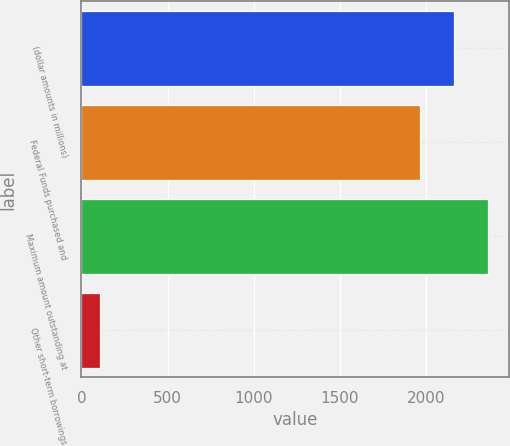Convert chart. <chart><loc_0><loc_0><loc_500><loc_500><bar_chart><fcel>(dollar amounts in millions)<fcel>Federal Funds purchased and<fcel>Maximum amount outstanding at<fcel>Other short-term borrowings<nl><fcel>2163.6<fcel>1966<fcel>2361.2<fcel>108<nl></chart> 